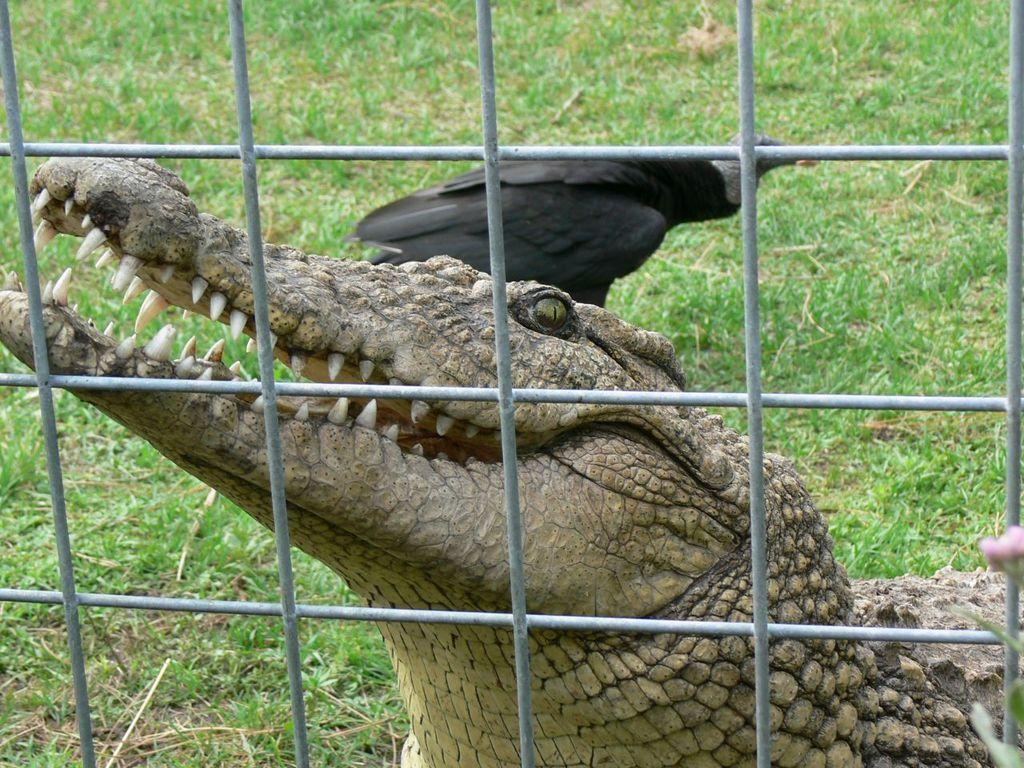What animals can be seen in the image? There is a crocodile and a crow in the image. Can you describe the location of the flower in the image? The flower is near steel fencing in the bottom right corner of the image. What type of vegetation is visible at the top of the image? There is grass visible at the top of the image. What time of day is the attraction operating in the image? There is no mention of an attraction or operation in the image, so it cannot be determined from the image. 